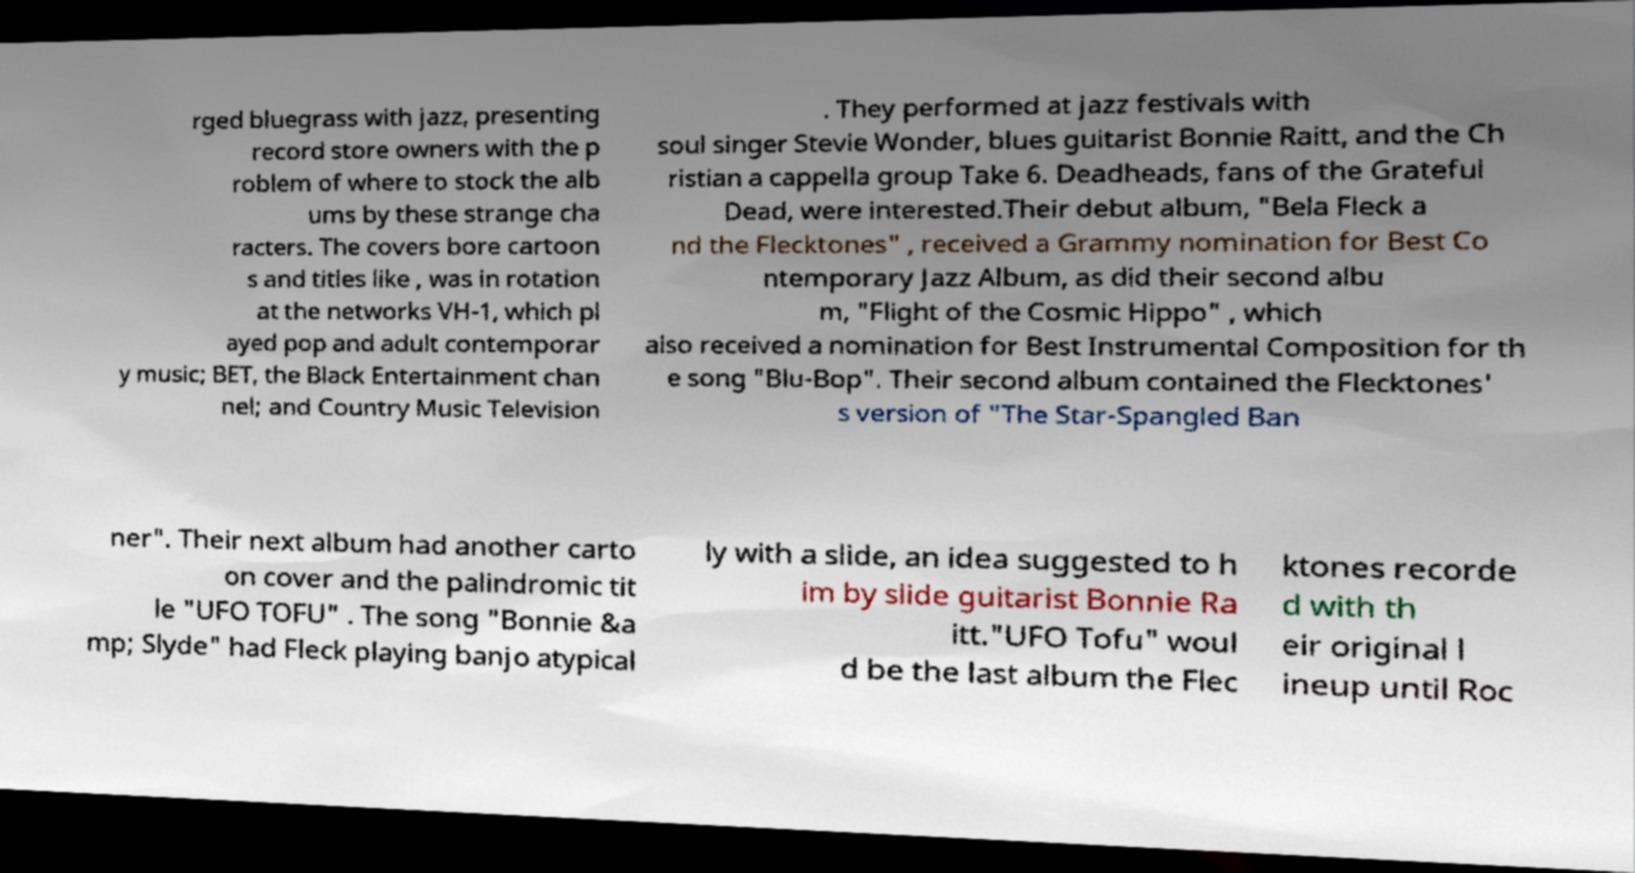There's text embedded in this image that I need extracted. Can you transcribe it verbatim? rged bluegrass with jazz, presenting record store owners with the p roblem of where to stock the alb ums by these strange cha racters. The covers bore cartoon s and titles like , was in rotation at the networks VH-1, which pl ayed pop and adult contemporar y music; BET, the Black Entertainment chan nel; and Country Music Television . They performed at jazz festivals with soul singer Stevie Wonder, blues guitarist Bonnie Raitt, and the Ch ristian a cappella group Take 6. Deadheads, fans of the Grateful Dead, were interested.Their debut album, "Bela Fleck a nd the Flecktones" , received a Grammy nomination for Best Co ntemporary Jazz Album, as did their second albu m, "Flight of the Cosmic Hippo" , which also received a nomination for Best Instrumental Composition for th e song "Blu-Bop". Their second album contained the Flecktones' s version of "The Star-Spangled Ban ner". Their next album had another carto on cover and the palindromic tit le "UFO TOFU" . The song "Bonnie &a mp; Slyde" had Fleck playing banjo atypical ly with a slide, an idea suggested to h im by slide guitarist Bonnie Ra itt."UFO Tofu" woul d be the last album the Flec ktones recorde d with th eir original l ineup until Roc 